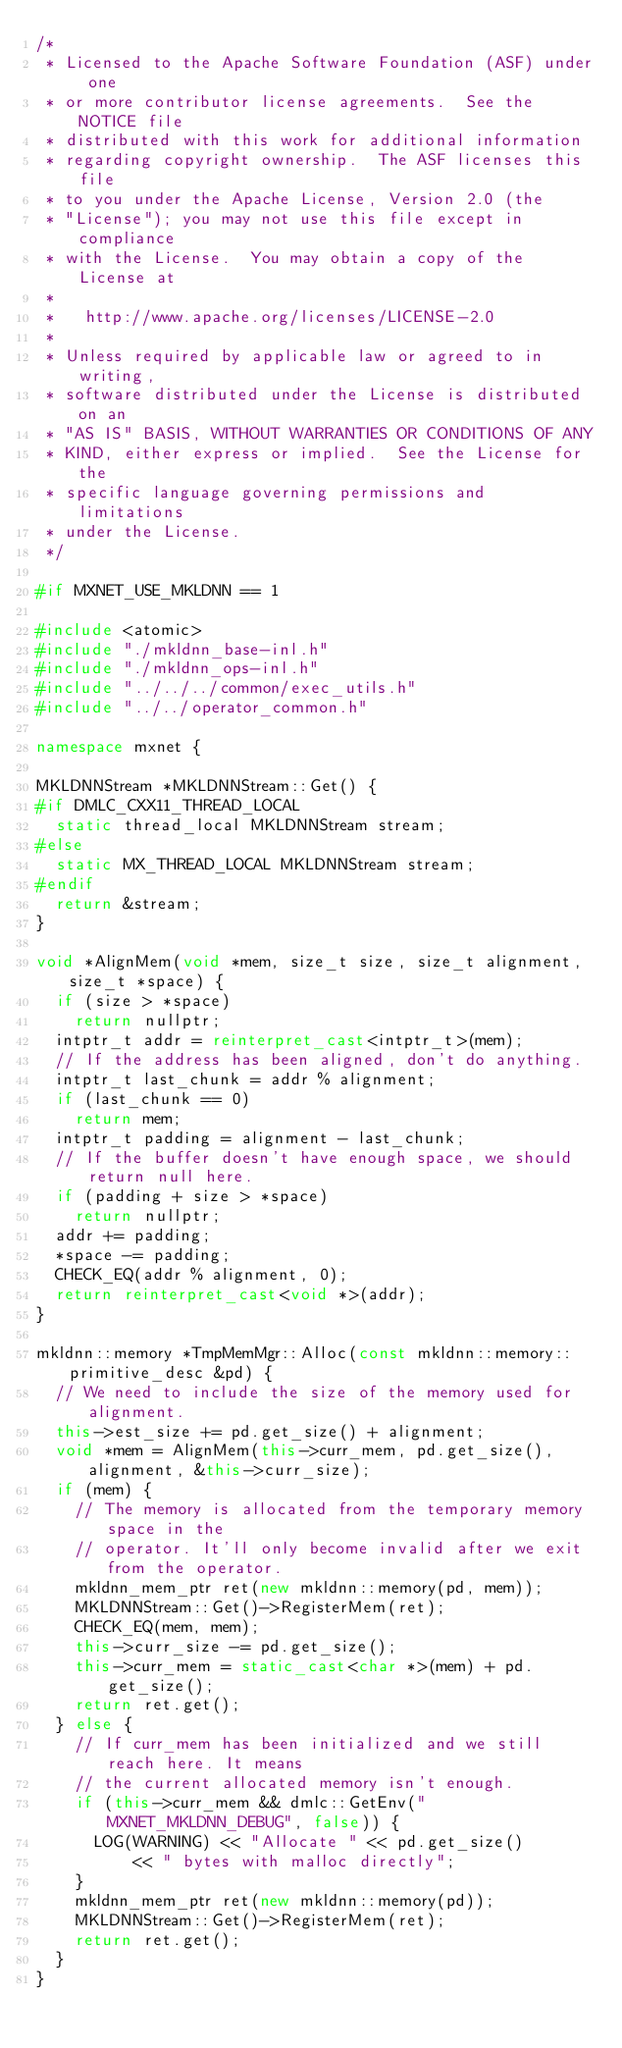Convert code to text. <code><loc_0><loc_0><loc_500><loc_500><_C++_>/*
 * Licensed to the Apache Software Foundation (ASF) under one
 * or more contributor license agreements.  See the NOTICE file
 * distributed with this work for additional information
 * regarding copyright ownership.  The ASF licenses this file
 * to you under the Apache License, Version 2.0 (the
 * "License"); you may not use this file except in compliance
 * with the License.  You may obtain a copy of the License at
 *
 *   http://www.apache.org/licenses/LICENSE-2.0
 *
 * Unless required by applicable law or agreed to in writing,
 * software distributed under the License is distributed on an
 * "AS IS" BASIS, WITHOUT WARRANTIES OR CONDITIONS OF ANY
 * KIND, either express or implied.  See the License for the
 * specific language governing permissions and limitations
 * under the License.
 */

#if MXNET_USE_MKLDNN == 1

#include <atomic>
#include "./mkldnn_base-inl.h"
#include "./mkldnn_ops-inl.h"
#include "../../../common/exec_utils.h"
#include "../../operator_common.h"

namespace mxnet {

MKLDNNStream *MKLDNNStream::Get() {
#if DMLC_CXX11_THREAD_LOCAL
  static thread_local MKLDNNStream stream;
#else
  static MX_THREAD_LOCAL MKLDNNStream stream;
#endif
  return &stream;
}

void *AlignMem(void *mem, size_t size, size_t alignment, size_t *space) {
  if (size > *space)
    return nullptr;
  intptr_t addr = reinterpret_cast<intptr_t>(mem);
  // If the address has been aligned, don't do anything.
  intptr_t last_chunk = addr % alignment;
  if (last_chunk == 0)
    return mem;
  intptr_t padding = alignment - last_chunk;
  // If the buffer doesn't have enough space, we should return null here.
  if (padding + size > *space)
    return nullptr;
  addr += padding;
  *space -= padding;
  CHECK_EQ(addr % alignment, 0);
  return reinterpret_cast<void *>(addr);
}

mkldnn::memory *TmpMemMgr::Alloc(const mkldnn::memory::primitive_desc &pd) {
  // We need to include the size of the memory used for alignment.
  this->est_size += pd.get_size() + alignment;
  void *mem = AlignMem(this->curr_mem, pd.get_size(), alignment, &this->curr_size);
  if (mem) {
    // The memory is allocated from the temporary memory space in the
    // operator. It'll only become invalid after we exit from the operator.
    mkldnn_mem_ptr ret(new mkldnn::memory(pd, mem));
    MKLDNNStream::Get()->RegisterMem(ret);
    CHECK_EQ(mem, mem);
    this->curr_size -= pd.get_size();
    this->curr_mem = static_cast<char *>(mem) + pd.get_size();
    return ret.get();
  } else {
    // If curr_mem has been initialized and we still reach here. It means
    // the current allocated memory isn't enough.
    if (this->curr_mem && dmlc::GetEnv("MXNET_MKLDNN_DEBUG", false)) {
      LOG(WARNING) << "Allocate " << pd.get_size()
          << " bytes with malloc directly";
    }
    mkldnn_mem_ptr ret(new mkldnn::memory(pd));
    MKLDNNStream::Get()->RegisterMem(ret);
    return ret.get();
  }
}
</code> 